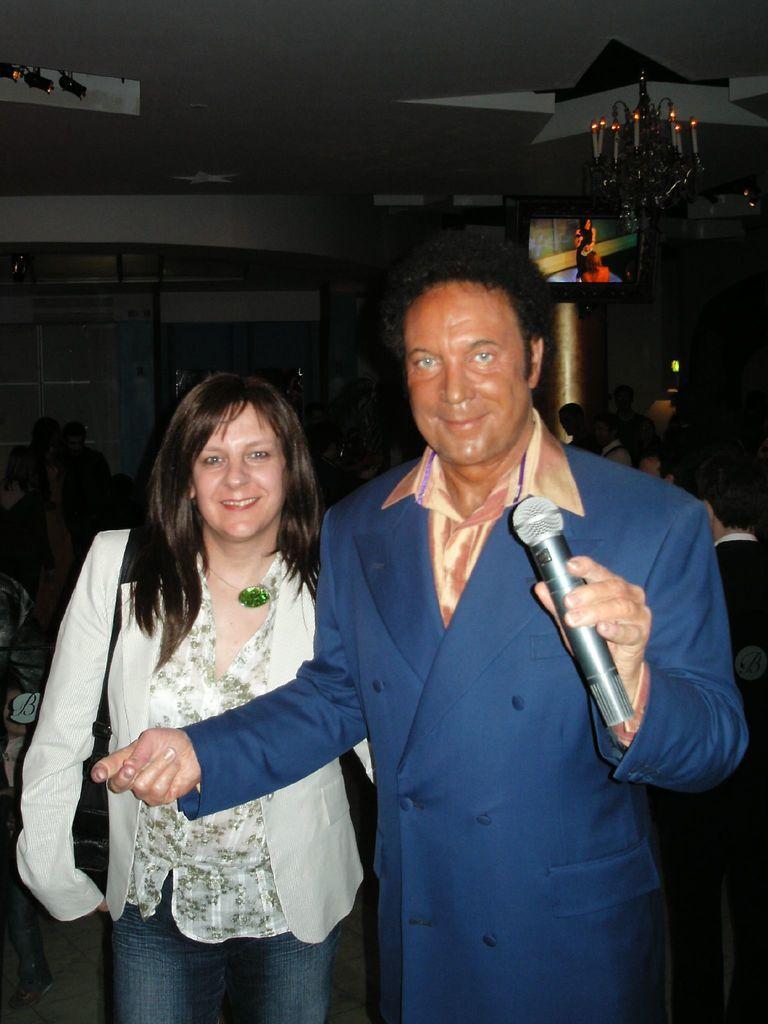Describe this image in one or two sentences. These two persons are standing,this person holding microphone and this person wear bag,behind these two persons we can see wall,pillar,persons. On the top we can see television,lights. 